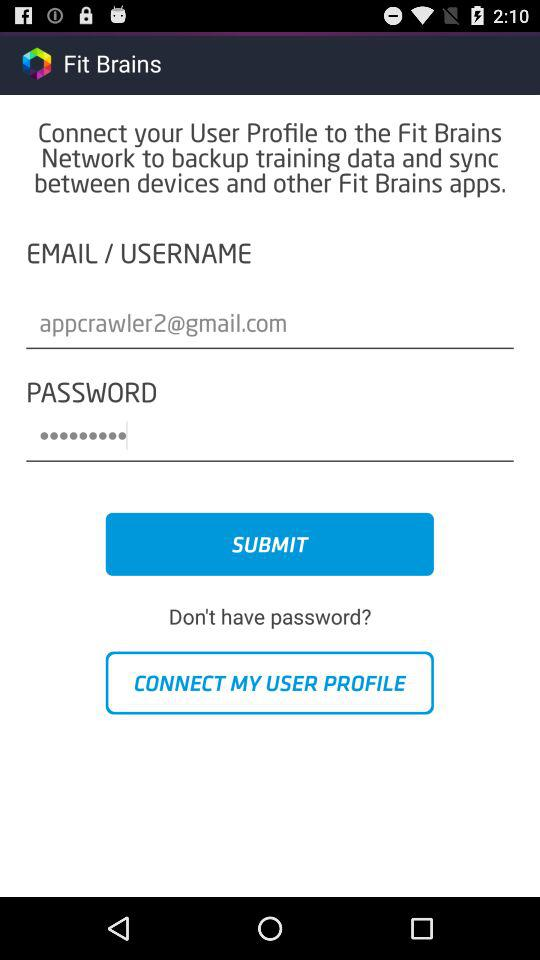What is the email address? The email address is "appcrawler2@gmail.com". 